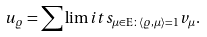Convert formula to latex. <formula><loc_0><loc_0><loc_500><loc_500>u _ { \varrho } = \sum \lim i t s _ { \mu \in \mathrm E \colon \langle \varrho , \mu \rangle = 1 } v _ { \mu } .</formula> 